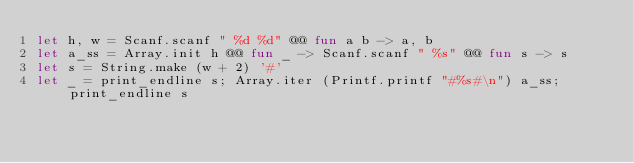<code> <loc_0><loc_0><loc_500><loc_500><_OCaml_>let h, w = Scanf.scanf " %d %d" @@ fun a b -> a, b
let a_ss = Array.init h @@ fun _ -> Scanf.scanf " %s" @@ fun s -> s
let s = String.make (w + 2) '#'
let _ = print_endline s; Array.iter (Printf.printf "#%s#\n") a_ss; print_endline s</code> 